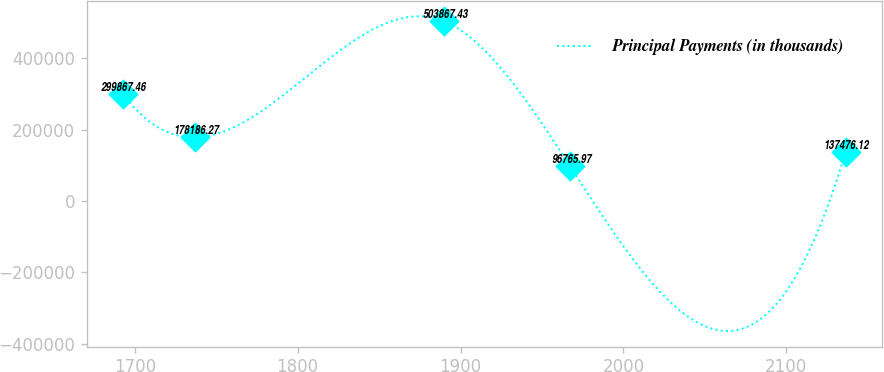Convert chart. <chart><loc_0><loc_0><loc_500><loc_500><line_chart><ecel><fcel>Principal Payments (in thousands)<nl><fcel>1692.67<fcel>299867<nl><fcel>1737.05<fcel>178186<nl><fcel>1889.79<fcel>503867<nl><fcel>1967.38<fcel>96766<nl><fcel>2136.49<fcel>137476<nl></chart> 